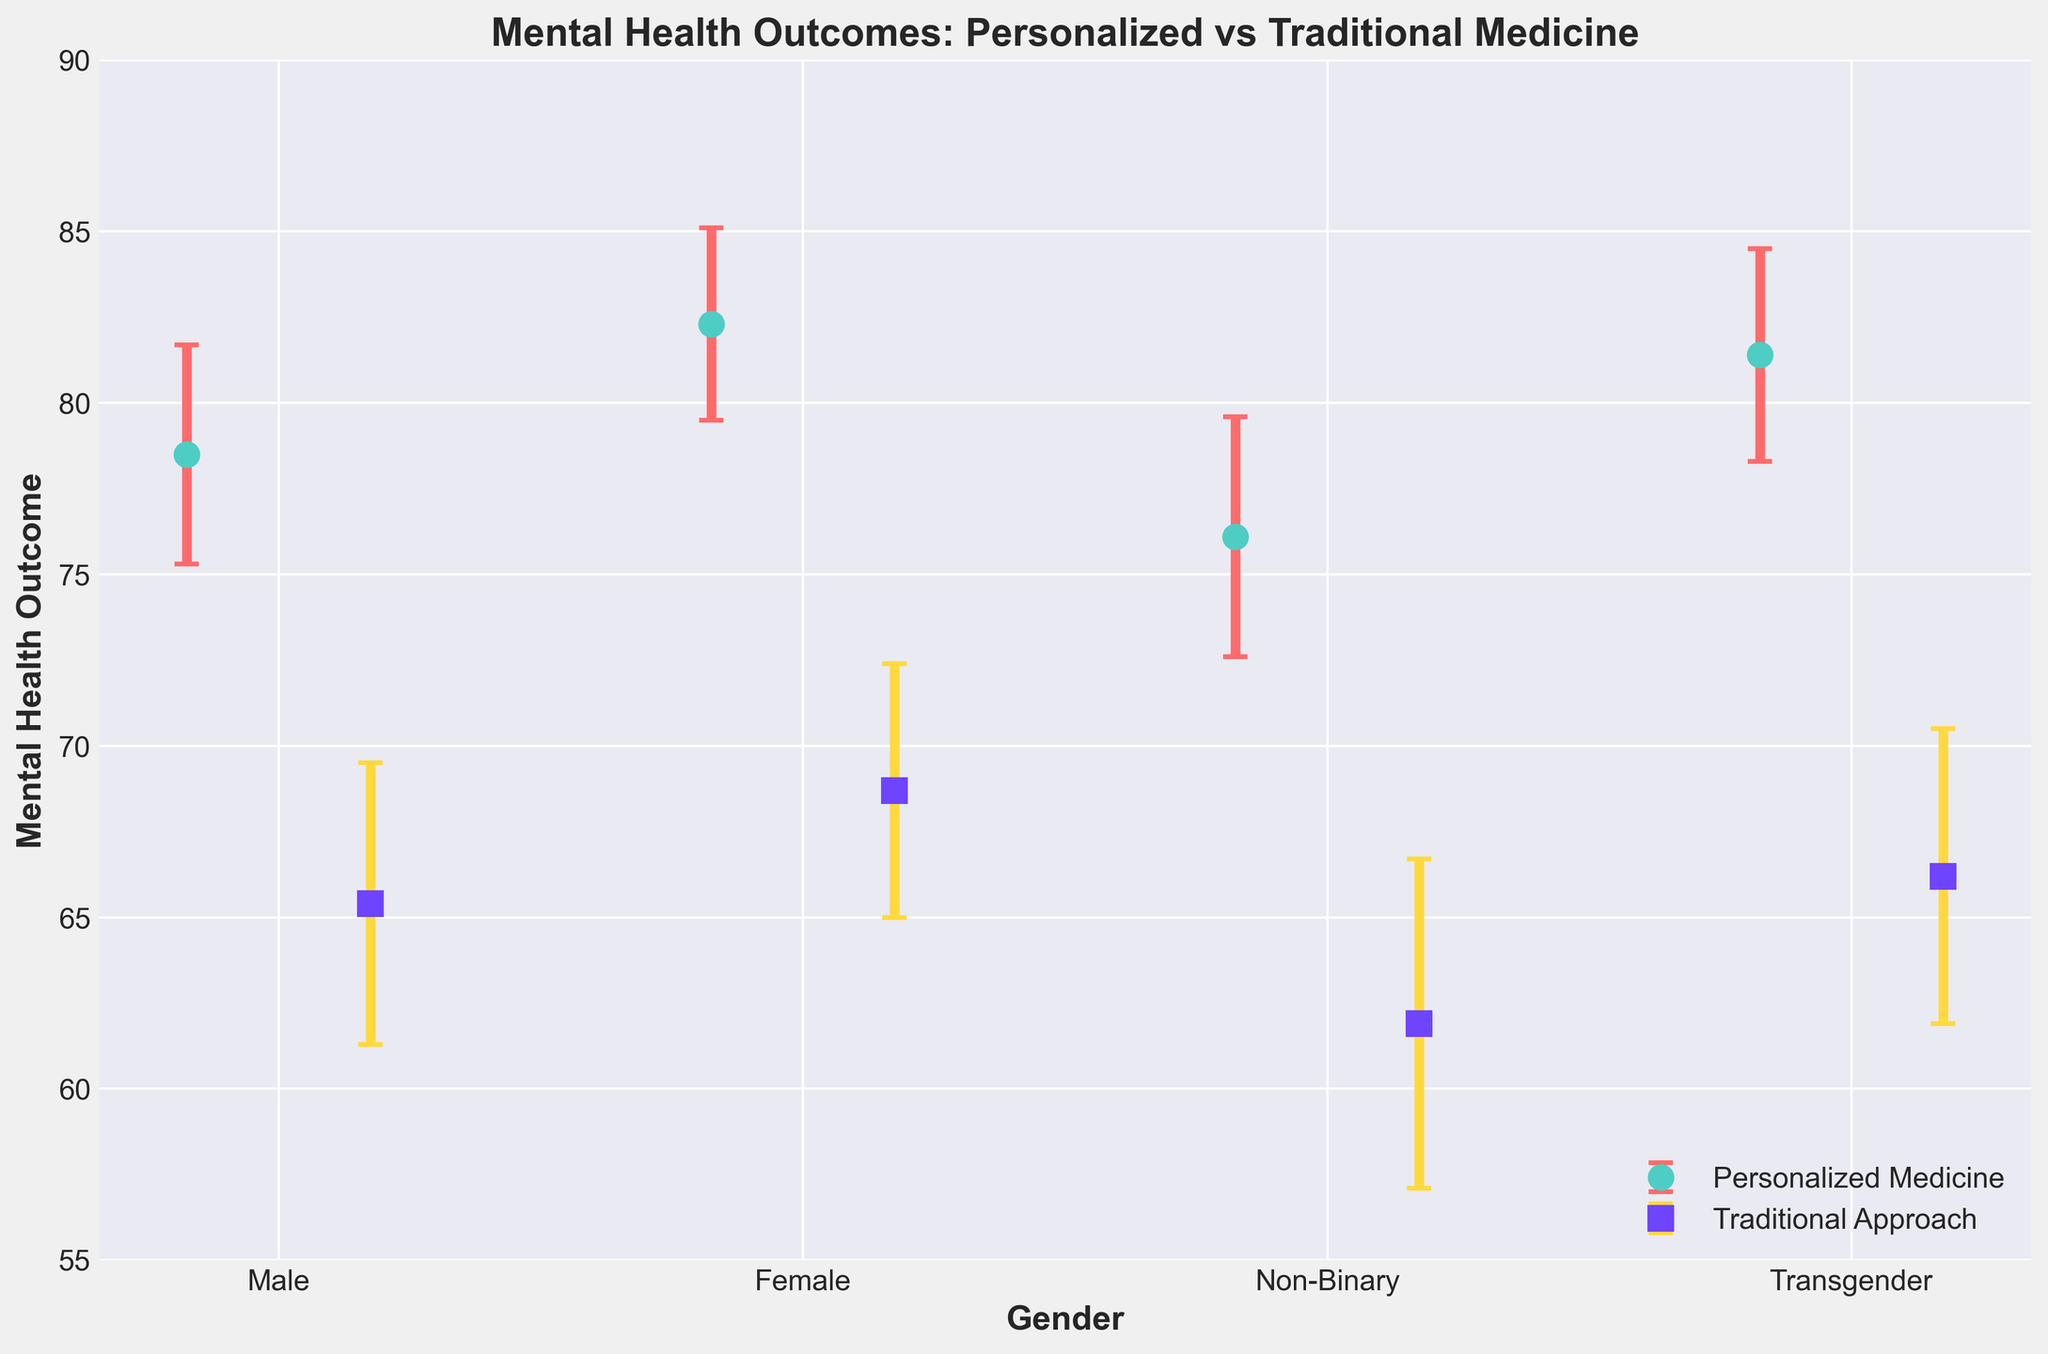How many gender categories are displayed in the figure? Count the distinct ticks on the x-axis corresponding to different genders.
Answer: 4 What approaches are being compared in the figure? Identify the labels in the legend which indicate the different approaches being compared.
Answer: Personalized Medicine and Traditional Approach Which gender category has the highest mean mental health outcome for personalized medicine? Locate the highest dot for personalized medicine considering the error bars on the y-axis.
Answer: Female For which gender category is the mean mental health outcome significantly lower for the traditional approach compared to personalized medicine? Compare the positions of the dots for traditional approach and personalized medicine for each gender. Significantly lower outcomes will be notably below those of personalized medicine.
Answer: Non-Binary What is the range of the y-axis in the figure? Read the minimum and maximum values on the y-axis.
Answer: 55 to 90 How does the mean mental health outcome for males compare between the personalized medicine and traditional approaches? Observe the dots representing males for both approaches and note the differences in their positions on the y-axis.
Answer: Higher for personalized medicine By how much does the mean mental health outcome for the female category differ between personalized medicine and traditional approaches? Determine the difference between the means of personalized medicine and traditional approaches for females by subtracting the lower value from the higher value.
Answer: 13.6 Are the error bars larger for males or non-binary for the traditional approach? Compare the lengths of the error bars below each dot in the traditional approach series for males and non-binary.
Answer: Non-Binary Which gender category has the closest mean mental health outcome for both personalized medicine and traditional approaches? Compare the gaps between the dots representing personalized medicine and traditional approaches for all gender categories. Identify the smallest gap.
Answer: Transgender What color represents traditional approach in the figure? Identify the color of the dots in the data series labeled for traditional approach in the legend.
Answer: Purple 